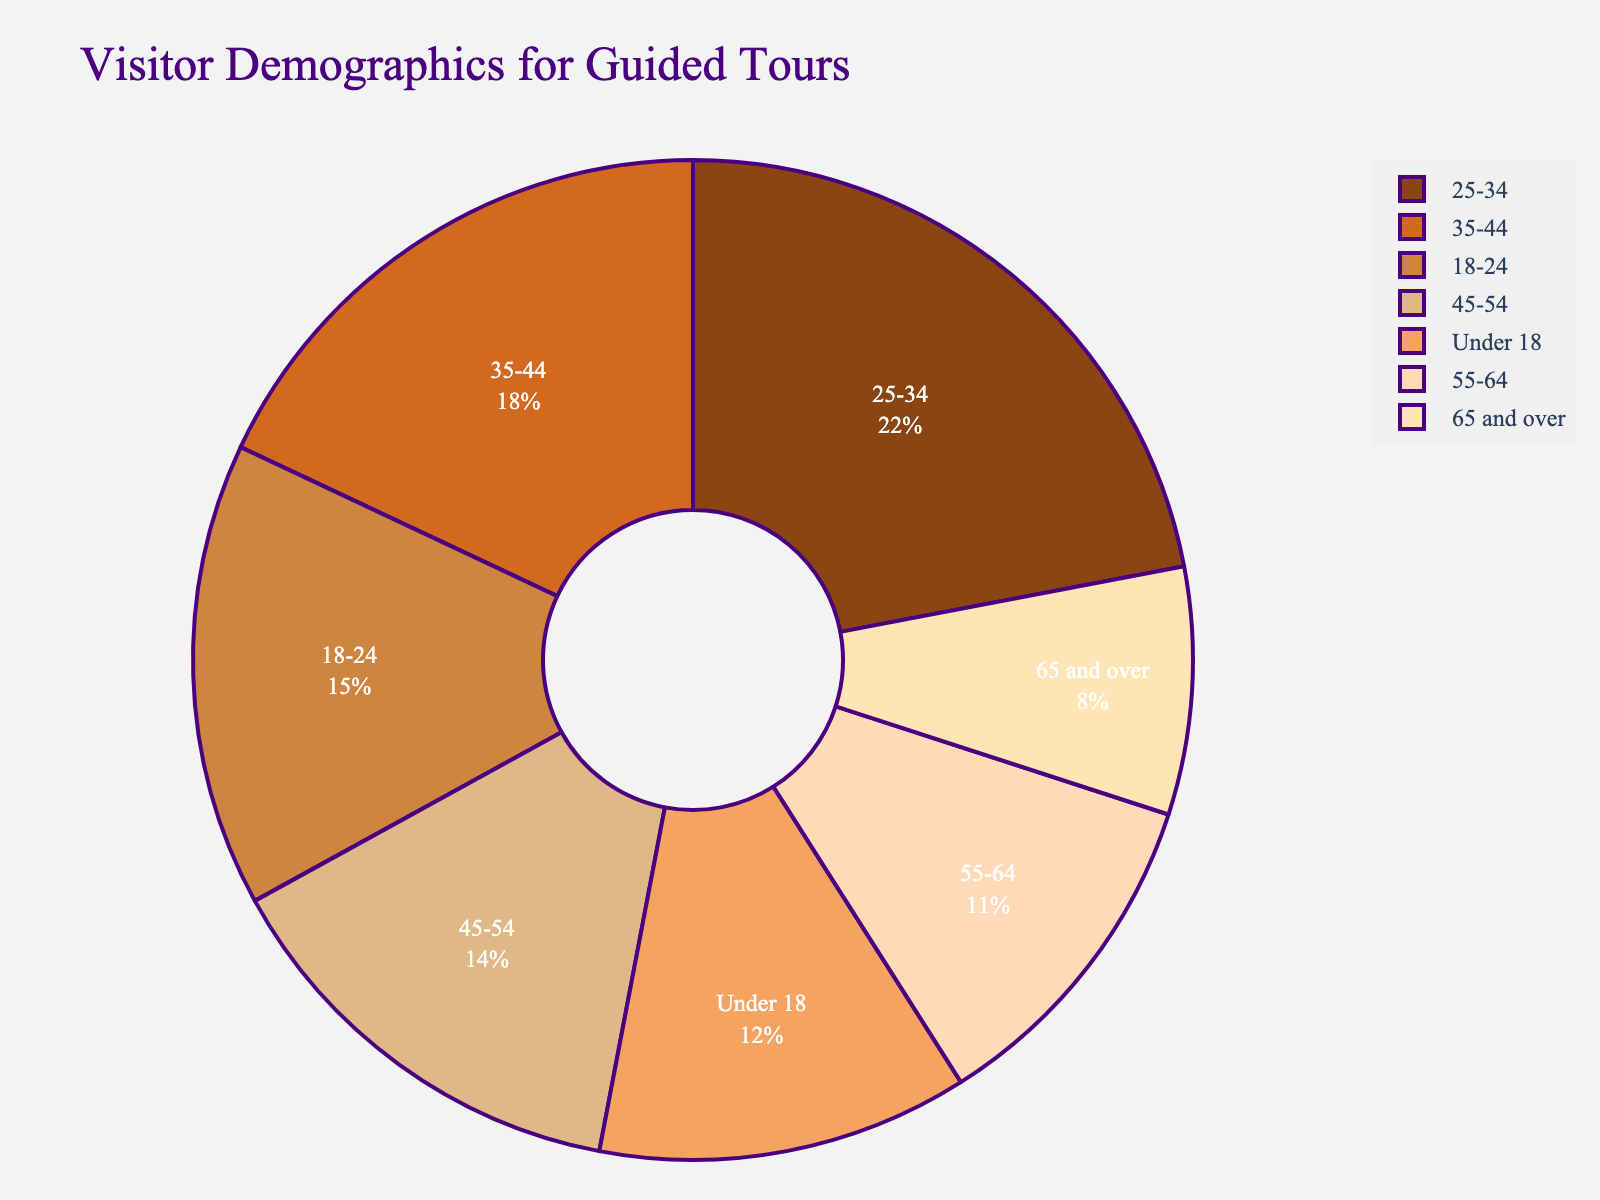What age group makes up the largest percentage of visitors? By looking at the pie chart, identify the segment with the biggest area. This represents the highest percentage. The 25-34 age group has the largest pie slice.
Answer: 25-34 Which age groups together make up the majority of the visitors? Add the percentages to see which combinations exceed 50%. The groups 25-34 (22%), 35-44 (18%), 18-24 (15%), and 45-54 (14%) together make up the majority.
Answer: 25-34, 35-44, 18-24, 45-54 What is the combined percentage of visitors aged 35 to 54? Sum up the percentages for 35-44 and 45-54 age groups: 18% + 14% = 32%.
Answer: 32% Does the percentage of visitors under 18 exceed 10%? Directly check the value in the pie chart for the under 18 age group. It's 12%, which is greater than 10%.
Answer: Yes How much larger is the 25-34 age group compared to the 65 and over age group? Subtract the percentage of the 65 and over group from the 25-34 group: 22% - 8% = 14%.
Answer: 14% Which two age groups have the smallest combined percentage of visitors? Identify the two smallest segments in the pie chart. The groups under 18 (12%) and 65 and over (8%) together make 20%.
Answer: Under 18, 65 and over What is the average percentage of visitors across the 18-24, 25-34, and 35-44 age groups? Add the percentages and divide by the number of groups: (15% + 22% + 18%) / 3 = 18.33%.
Answer: 18.33% Are there more visitors in the 45-54 age group than in the 55-64 age group? Compare the two percentages: 14% for 45-54 and 11% for 55-64. 14% is greater than 11%.
Answer: Yes What is the difference in percentage between the two most similar age groups? Find the closest values: 55-64 (11%) and 65 and over (8%) are closest. The difference is 11% - 8% = 3%.
Answer: 3% 